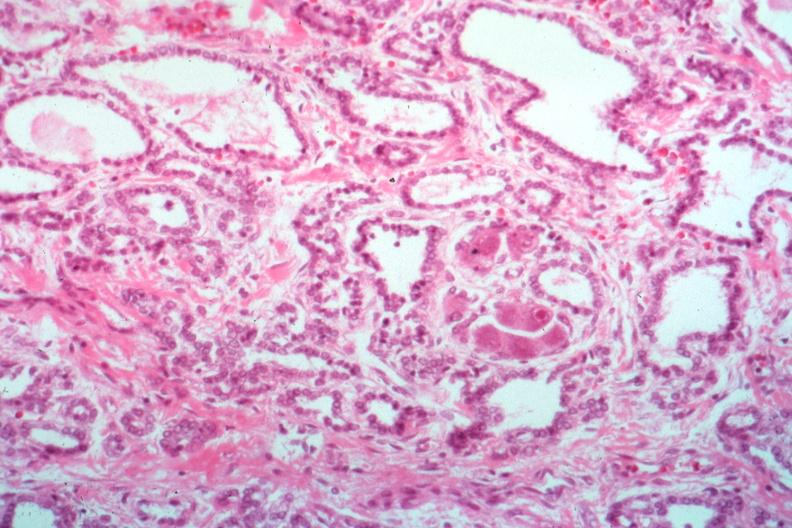s thyroid present?
Answer the question using a single word or phrase. Yes 